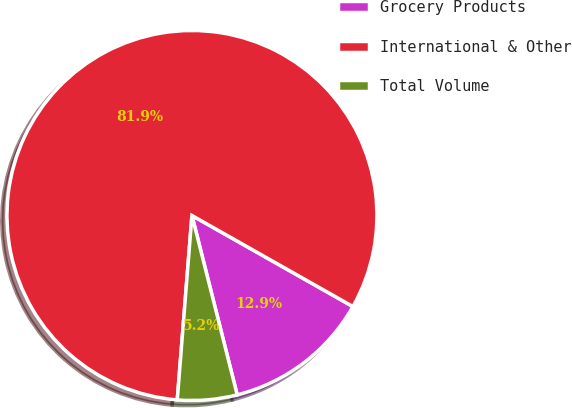Convert chart. <chart><loc_0><loc_0><loc_500><loc_500><pie_chart><fcel>Grocery Products<fcel>International & Other<fcel>Total Volume<nl><fcel>12.87%<fcel>81.92%<fcel>5.2%<nl></chart> 